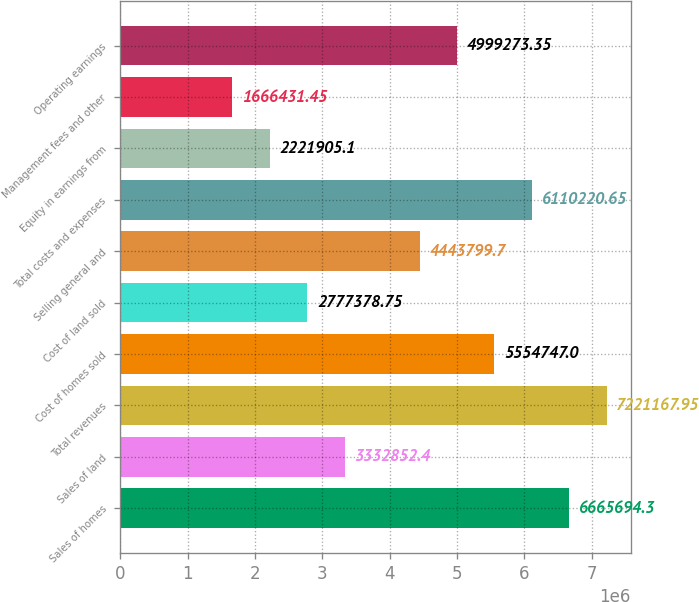Convert chart. <chart><loc_0><loc_0><loc_500><loc_500><bar_chart><fcel>Sales of homes<fcel>Sales of land<fcel>Total revenues<fcel>Cost of homes sold<fcel>Cost of land sold<fcel>Selling general and<fcel>Total costs and expenses<fcel>Equity in earnings from<fcel>Management fees and other<fcel>Operating earnings<nl><fcel>6.66569e+06<fcel>3.33285e+06<fcel>7.22117e+06<fcel>5.55475e+06<fcel>2.77738e+06<fcel>4.4438e+06<fcel>6.11022e+06<fcel>2.22191e+06<fcel>1.66643e+06<fcel>4.99927e+06<nl></chart> 